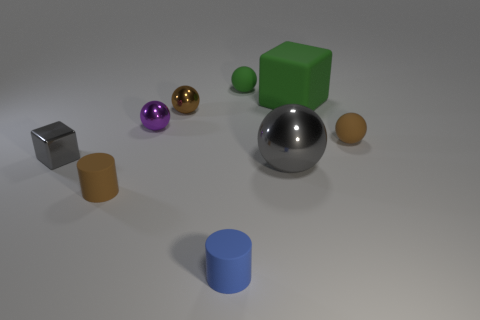How many shiny objects are purple balls or gray objects?
Give a very brief answer. 3. Is there a large rubber thing?
Make the answer very short. Yes. Is the brown metal object the same shape as the large green rubber object?
Provide a succinct answer. No. What number of big balls are behind the tiny brown matte object behind the gray thing left of the small green thing?
Your answer should be very brief. 0. What material is the small object that is both left of the blue cylinder and in front of the large metallic object?
Your answer should be compact. Rubber. There is a sphere that is right of the small green matte thing and behind the metallic block; what color is it?
Your answer should be compact. Brown. Is there anything else that has the same color as the big rubber object?
Make the answer very short. Yes. There is a small gray object left of the small brown matte thing in front of the tiny sphere right of the big gray shiny thing; what is its shape?
Ensure brevity in your answer.  Cube. What is the color of the other small metal object that is the same shape as the small purple thing?
Provide a succinct answer. Brown. What is the color of the tiny object that is behind the big thing behind the small gray metallic cube?
Offer a terse response. Green. 